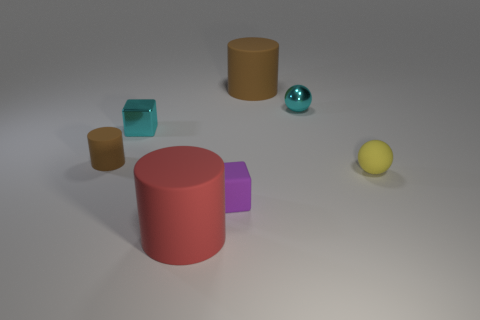Are there any rubber objects that have the same size as the cyan metal ball? Based on the visual information provided, it is not possible to precisely determine the material composition of the objects without additional context. However, if we assume the objects that closely resemble the size of the cyan metal ball are made of rubber, then there are no rubber objects that are clearly of the same size visible in the image. 